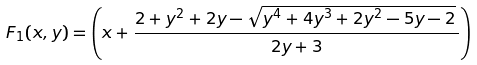<formula> <loc_0><loc_0><loc_500><loc_500>F _ { 1 } ( x , y ) = \left ( x + \frac { 2 + y ^ { 2 } + 2 y - \sqrt { y ^ { 4 } + 4 y ^ { 3 } + 2 y ^ { 2 } - 5 y - 2 } \, } { 2 y + 3 } \right )</formula> 